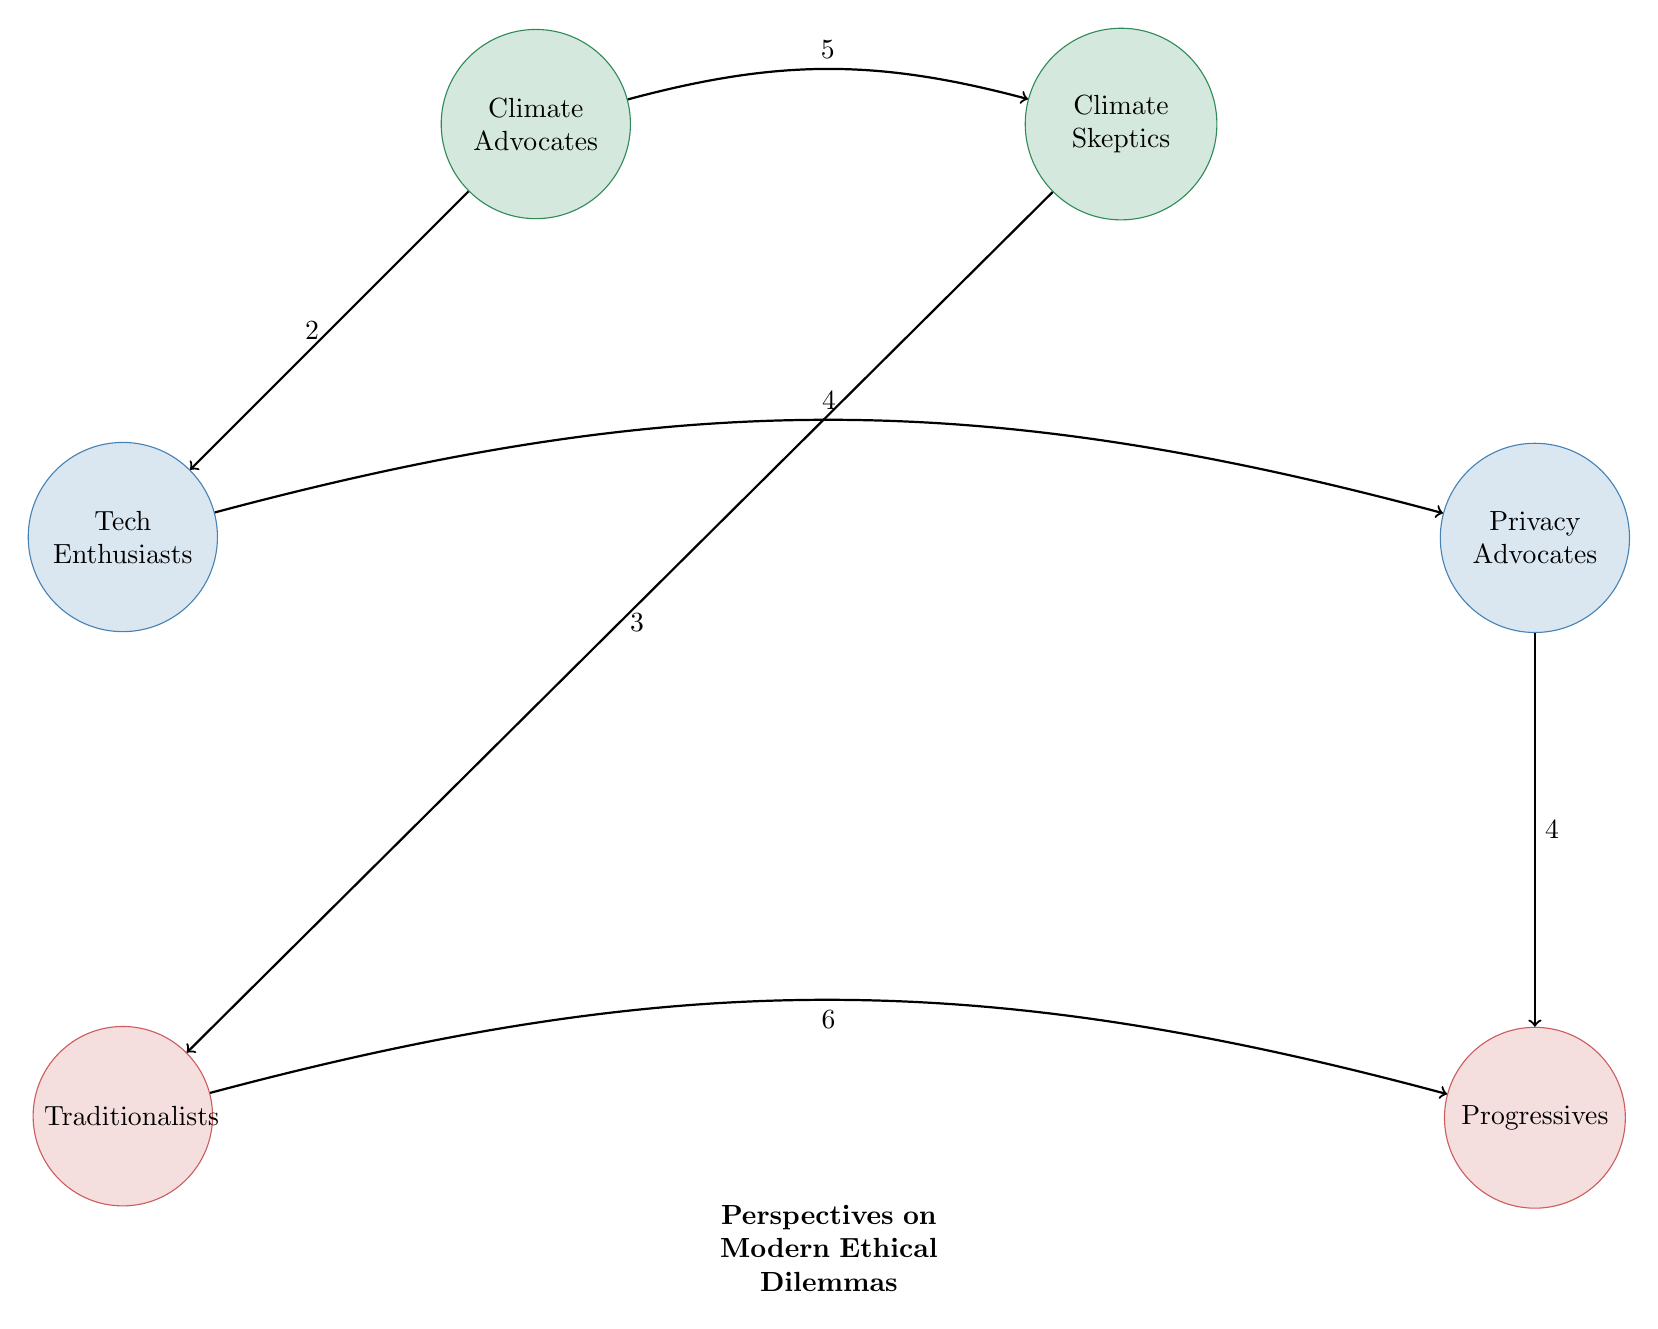What is the value of the link between Climate Advocates and Climate Skeptics? The diagram shows an arrow from Climate Advocates to Climate Skeptics labeled with a value of 5. This indicates the strength or significance of the connection between these two groups regarding their viewpoints on climate change.
Answer: 5 How many nodes are there in total? By counting all distinct circles in the diagram, we find six nodes: Climate Advocates, Climate Skeptics, Tech Enthusiasts, Privacy Advocates, Traditionalists, and Progressives. Thus, the total number of nodes is six.
Answer: 6 What is the value of the link from Traditionalists to Progressives? In the diagram, there is an arrow from Traditionalists to Progressives labeled with a value of 6. This value represents the strength of the connection or the intensity of interaction regarding societal norms between these two groups.
Answer: 6 Which two groups have the strongest relationship in the context of technology use? The two groups in the technology use category are Tech Enthusiasts and Privacy Advocates. The diagram shows a link between them, labeled with a value of 4, which indicates they have a significant degree of interaction regarding technology use, but the highest interaction in this category is not specified. The strongest relationship between them can be interpreted from that value.
Answer: Tech Enthusiasts and Privacy Advocates What is the lowest link value in the diagram? When reviewing the links displayed in the diagram, the connection with the lowest value is between Climate Advocates and Tech Enthusiasts, which is labeled with a value of 2. This indicates the least strength of interaction among the pairs shown in the diagram.
Answer: 2 What are the groups that connect directly via the link with the value of 4? The diagram shows two distinct connections with a value of 4: one between Tech Enthusiasts and Privacy Advocates, and another between Privacy Advocates and Progressives. Thus, the connecting groups are Tech Enthusiasts and Privacy Advocates or Privacy Advocates and Progressives.
Answer: Tech Enthusiasts and Privacy Advocates, Privacy Advocates and Progressives How many links connect the Climate Advocates group? The Climate Advocates group is connected by two links: one to Climate Skeptics with a value of 5 and another to Tech Enthusiasts with a value of 2. Therefore, there are two distinct links originating from Climate Advocates.
Answer: 2 Which group has the highest number of connections? By analyzing the linkages, Traditionalists have connections to two groups: Climate Skeptics (3) and Progressives (6). Since no other group has more than two connections, Traditionalists have the highest number of connections depicted in the diagram.
Answer: Traditionalists 